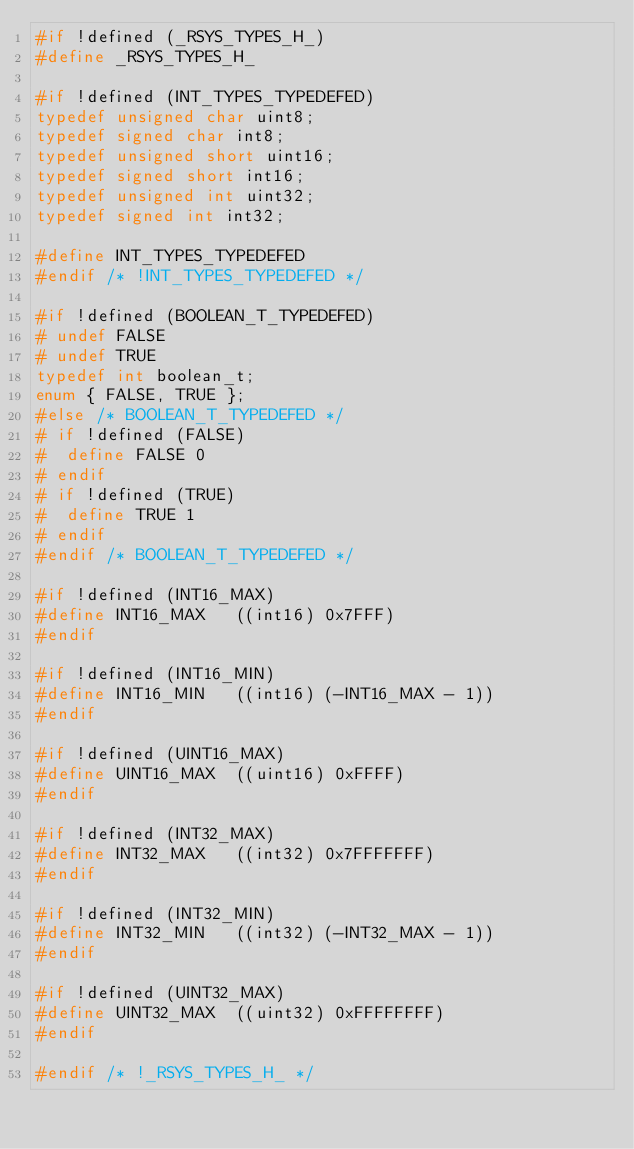Convert code to text. <code><loc_0><loc_0><loc_500><loc_500><_C_>#if !defined (_RSYS_TYPES_H_)
#define _RSYS_TYPES_H_

#if !defined (INT_TYPES_TYPEDEFED)
typedef unsigned char uint8;
typedef signed char int8;
typedef unsigned short uint16;
typedef signed short int16;
typedef unsigned int uint32;
typedef signed int int32;

#define INT_TYPES_TYPEDEFED
#endif /* !INT_TYPES_TYPEDEFED */

#if !defined (BOOLEAN_T_TYPEDEFED)
# undef FALSE
# undef TRUE
typedef int boolean_t;
enum { FALSE, TRUE };
#else /* BOOLEAN_T_TYPEDEFED */
# if !defined (FALSE)
#  define FALSE 0
# endif
# if !defined (TRUE)
#  define TRUE 1
# endif
#endif /* BOOLEAN_T_TYPEDEFED */

#if !defined (INT16_MAX)
#define INT16_MAX	((int16) 0x7FFF)
#endif

#if !defined (INT16_MIN)
#define INT16_MIN	((int16) (-INT16_MAX - 1))
#endif

#if !defined (UINT16_MAX)
#define UINT16_MAX	((uint16) 0xFFFF)
#endif

#if !defined (INT32_MAX)
#define INT32_MAX	((int32) 0x7FFFFFFF)
#endif

#if !defined (INT32_MIN)
#define INT32_MIN	((int32) (-INT32_MAX - 1))
#endif

#if !defined (UINT32_MAX)
#define UINT32_MAX	((uint32) 0xFFFFFFFF)
#endif

#endif /* !_RSYS_TYPES_H_ */
</code> 